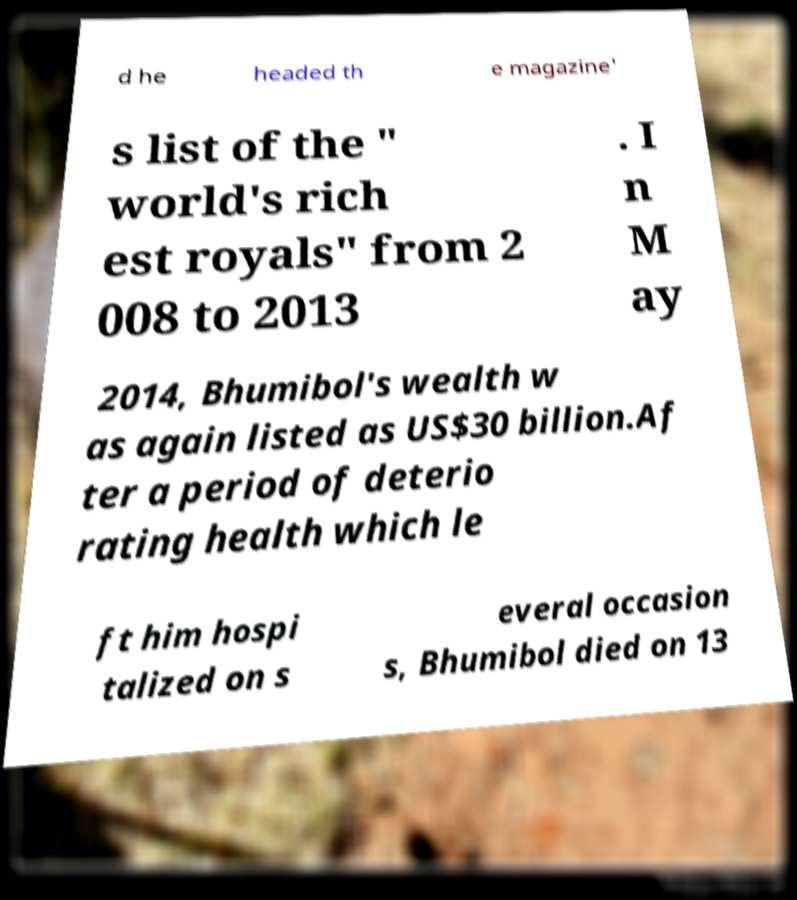Could you assist in decoding the text presented in this image and type it out clearly? d he headed th e magazine' s list of the " world's rich est royals" from 2 008 to 2013 . I n M ay 2014, Bhumibol's wealth w as again listed as US$30 billion.Af ter a period of deterio rating health which le ft him hospi talized on s everal occasion s, Bhumibol died on 13 